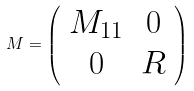<formula> <loc_0><loc_0><loc_500><loc_500>M = \left ( \begin{array} { c c } M _ { 1 1 } & 0 \\ 0 & R \end{array} \right )</formula> 